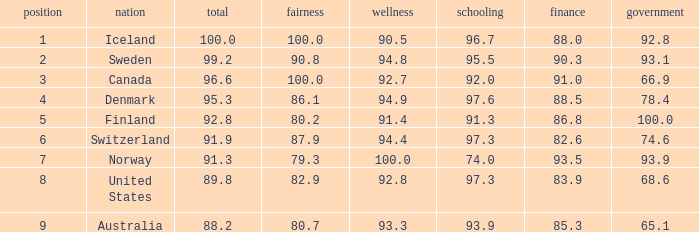What's the country with health being 91.4 Finland. 